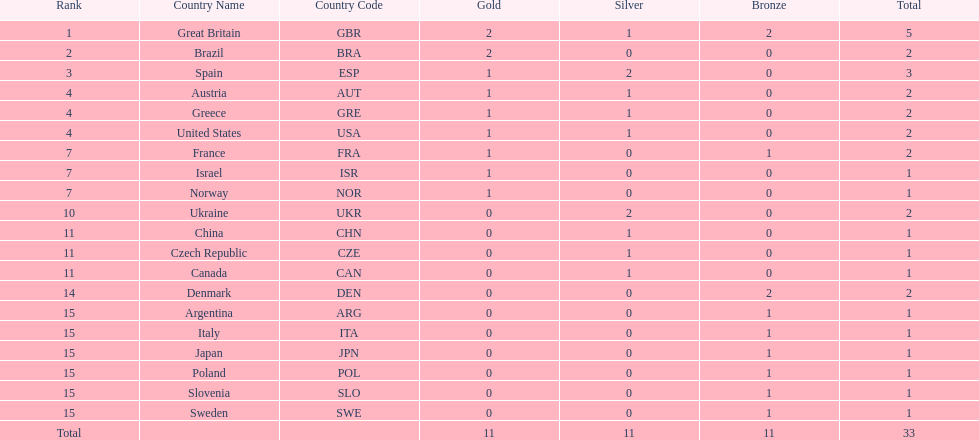How many gold medals did italy receive? 0. 